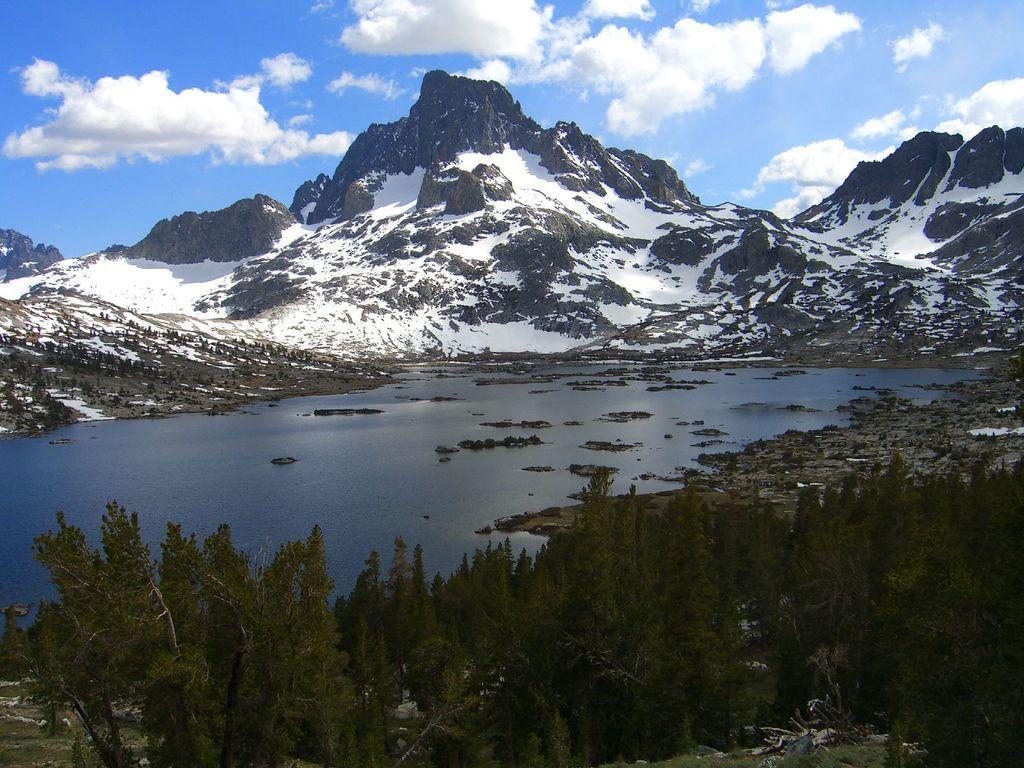In one or two sentences, can you explain what this image depicts? In the center of the image there is water. At the bottom we can see trees. In the background there are hills and sky. 